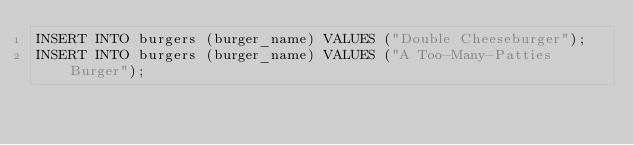Convert code to text. <code><loc_0><loc_0><loc_500><loc_500><_SQL_>INSERT INTO burgers (burger_name) VALUES ("Double Cheeseburger");
INSERT INTO burgers (burger_name) VALUES ("A Too-Many-Patties Burger");</code> 